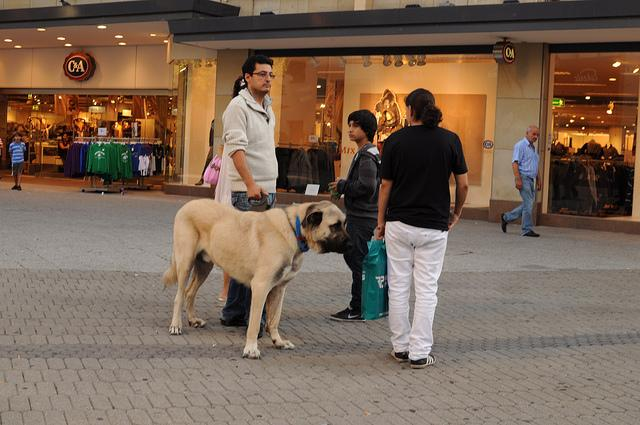What activity are the people shown involved in?

Choices:
A) shopping
B) sleeping
C) dog walking
D) selling shopping 